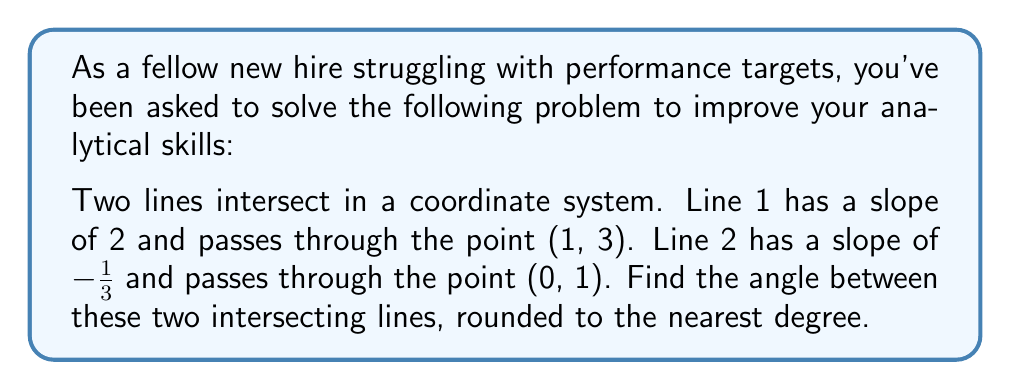Teach me how to tackle this problem. Let's approach this step-by-step:

1) First, recall the formula for finding the angle θ between two lines with slopes $m_1$ and $m_2$:

   $$\tan θ = \left|\frac{m_1 - m_2}{1 + m_1m_2}\right|$$

2) We're given:
   Line 1: $m_1 = 2$
   Line 2: $m_2 = -\frac{1}{3}$

3) Let's substitute these into our formula:

   $$\tan θ = \left|\frac{2 - (-\frac{1}{3})}{1 + 2(-\frac{1}{3})}\right|$$

4) Simplify the numerator and denominator:

   $$\tan θ = \left|\frac{2 + \frac{1}{3}}{1 - \frac{2}{3}}\right| = \left|\frac{\frac{6}{3} + \frac{1}{3}}{\frac{3}{3} - \frac{2}{3}}\right| = \left|\frac{\frac{7}{3}}{\frac{1}{3}}\right|$$

5) Divide:

   $$\tan θ = 7$$

6) To find θ, we need to take the inverse tangent (arctan) of both sides:

   $$θ = \arctan(7)$$

7) Using a calculator and rounding to the nearest degree:

   $$θ ≈ 82°$$
Answer: $82°$ 